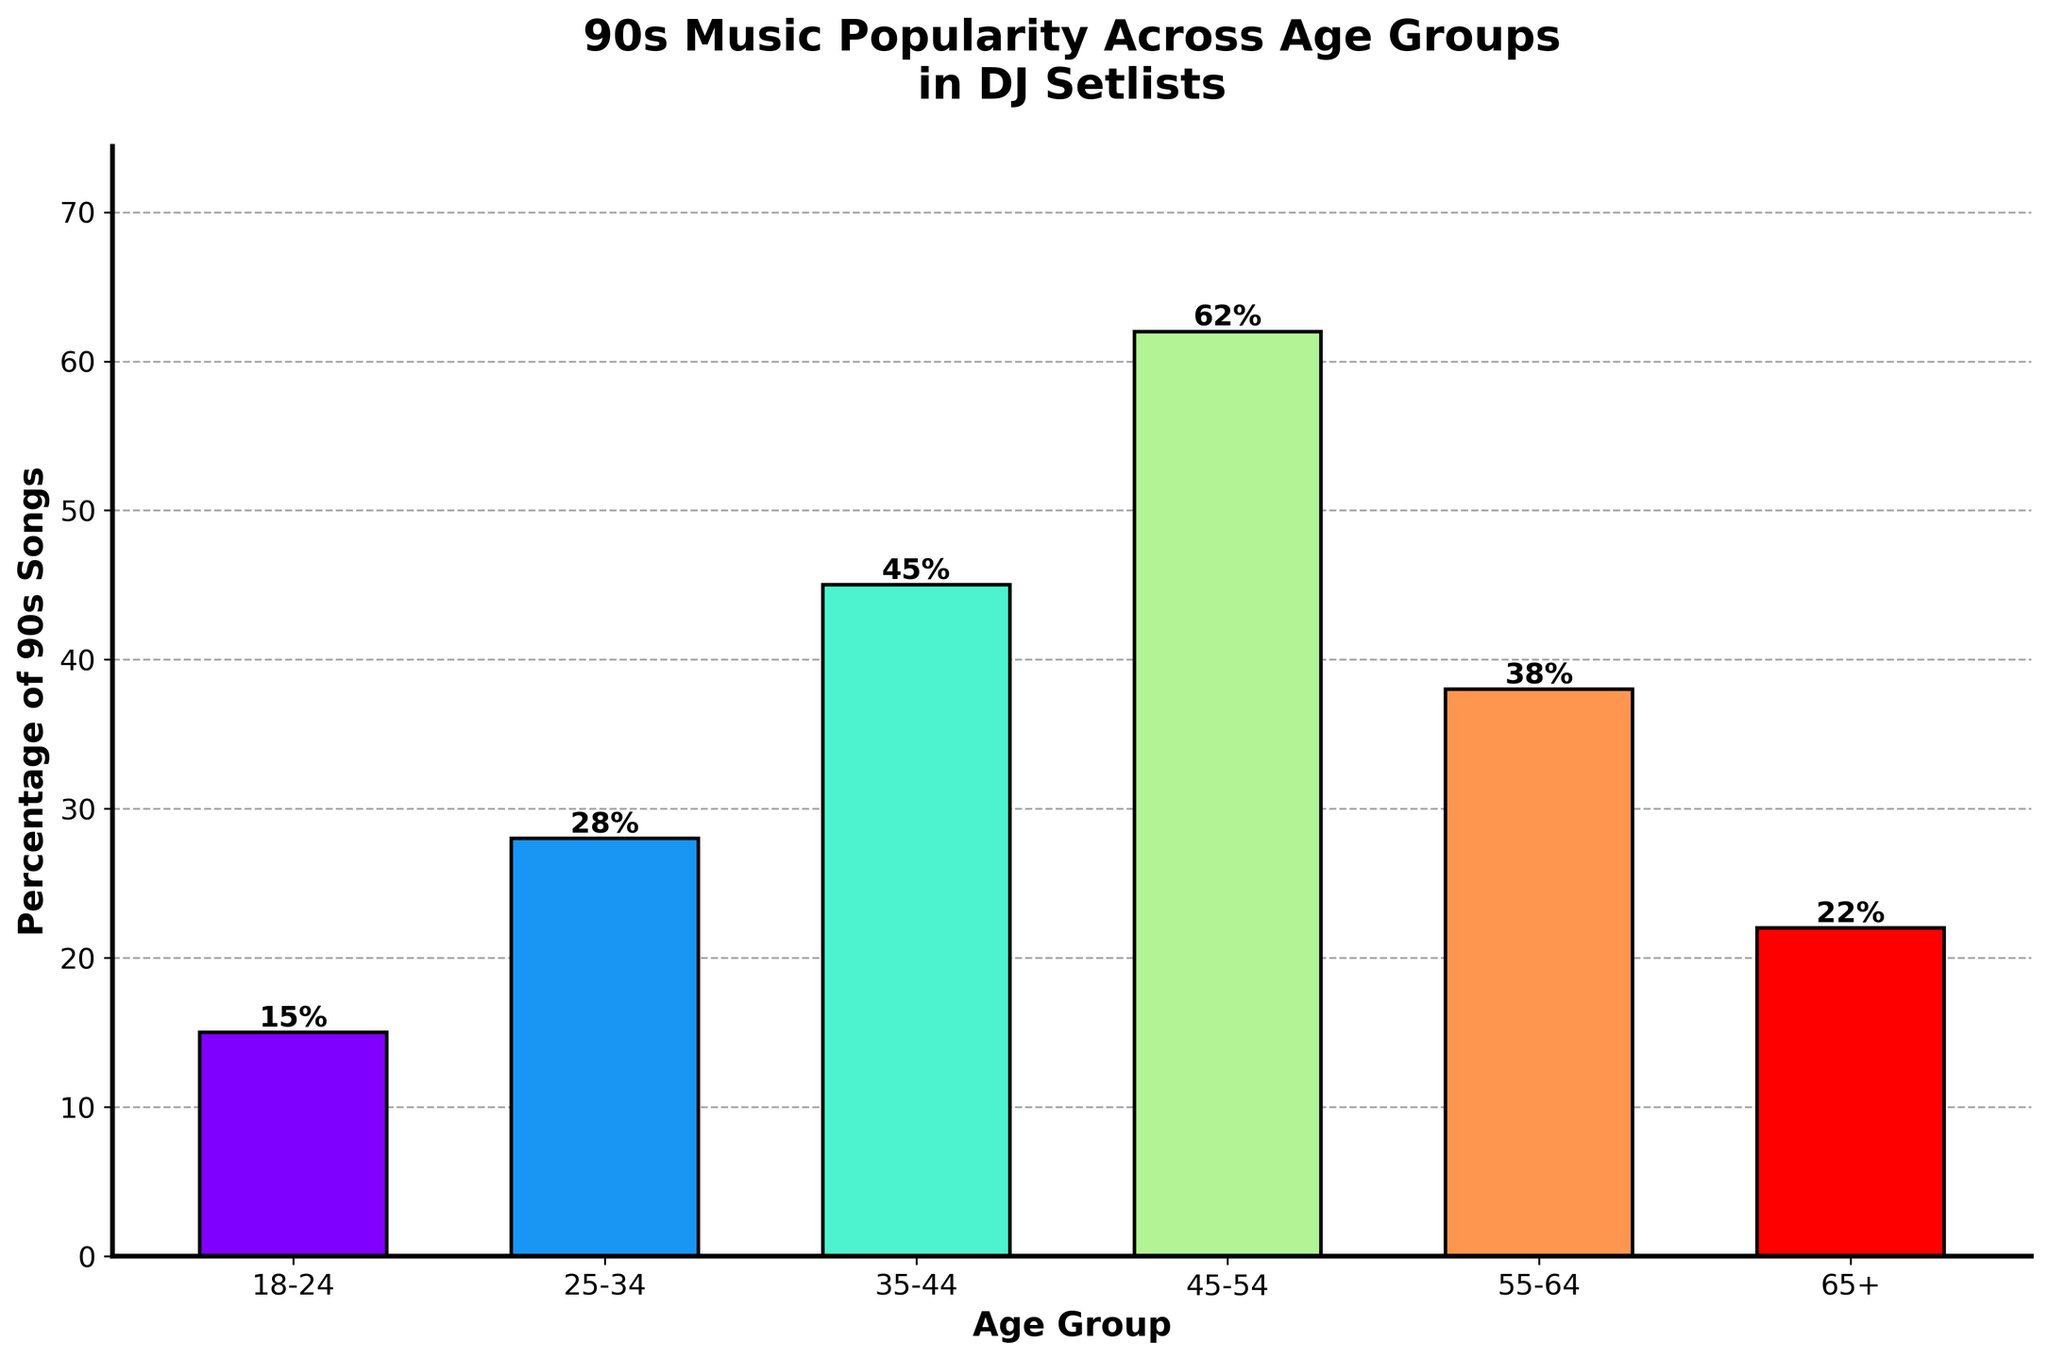Which age group has the highest percentage of 90s songs in DJ setlists? The highest percentage is represented by the tallest bar in the chart. The age group 45-54 has the highest bar at 62%.
Answer: 45-54 What is the average percentage of 90s songs for the 18-24 and 25-34 age groups? Add the percentages of the 18-24 and 25-34 age groups and divide by 2. (15 + 28) / 2 = 21.5%
Answer: 21.5% How much higher is the percentage of 90s songs for the 45-54 age group compared to the 18-24 age group? Subtract the percentage of the 18-24 age group from the percentage of the 45-54 age group. 62 - 15 = 47%
Answer: 47% Which two age groups have the closest percentages of 90s songs? Compare the differences between each age group. The closest percentages are for the 55-64 and 65+ age groups, with a difference of 16 points (38 - 22).
Answer: 55-64 and 65+ Is the percentage of 90s songs higher for the 35-44 age group or the 55-64 age group? Compare the heights of the bars for the 35-44 and 55-64 age groups. The 35-44 age group has a higher percentage (45%) compared to the 55-64 age group (38%).
Answer: 35-44 What is the total percentage of 90s songs for the age groups under 35? Add the percentages for the 18-24 and 25-34 age groups. 15 + 28 = 43%
Answer: 43% What's the percentage difference between the two groups with the highest values and the lowest values? Identify the highest (45-54 at 62%) and lowest (18-24 at 15%) percentages and calculate the difference. 62 - 15 = 47%
Answer: 47% If we consider the age groups 35-44 and 45-54 combined, what's the average percentage of 90s songs? Add the percentages of the 35-44 and 45-54 age groups and divide by 2. (45 + 62) / 2 = 53.5%
Answer: 53.5% Which age group has a percentage of 90s songs closest to 40%? Compare each age group's percentage to 40%. The 55-64 age group is the closest with 38%.
Answer: 55-64 Which two neighboring age groups have the largest difference in the percentage of 90s songs? Compare differences between consecutive age groups. The largest difference is between the 45-54 (62%) and 55-64 (38%) age groups, with a difference of 24 points.
Answer: 45-54 and 55-64 